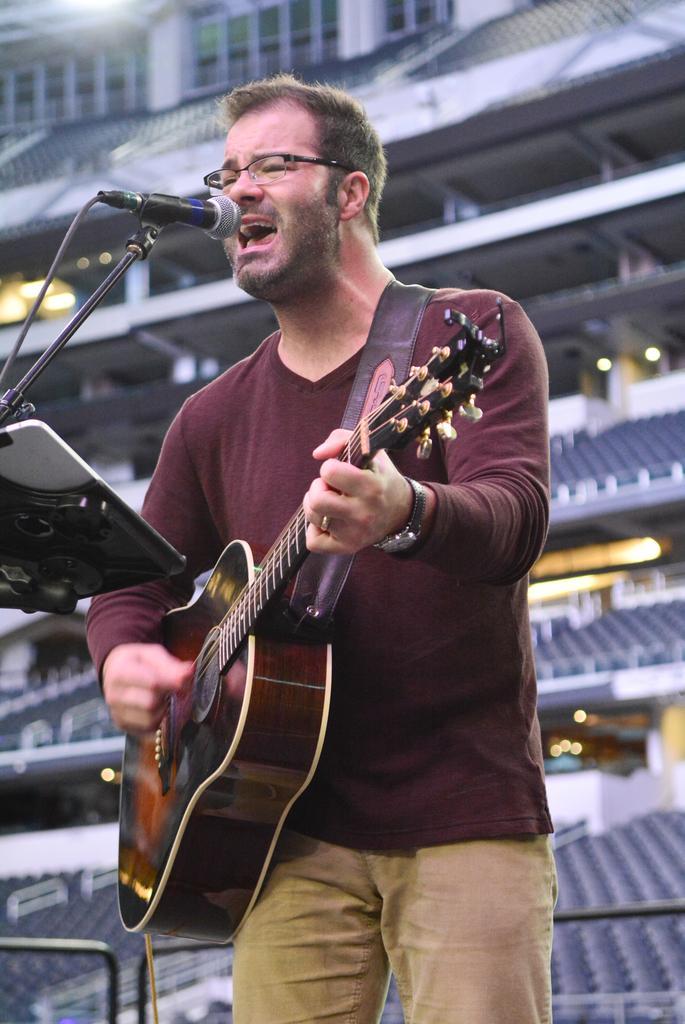Describe this image in one or two sentences. Here is the man standing and singing a song. He is playing guitar. This is a mic attached to the mike stand. At background this looks like a stadium. 